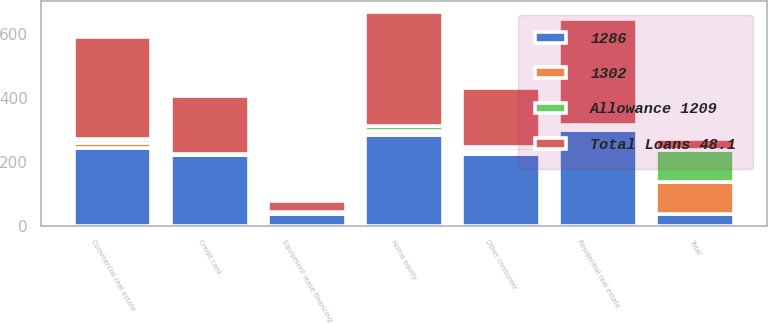Convert chart to OTSL. <chart><loc_0><loc_0><loc_500><loc_500><stacked_bar_chart><ecel><fcel>Commercial real estate<fcel>Equipment lease financing<fcel>Home equity<fcel>Residential real estate<fcel>Credit card<fcel>Other consumer<fcel>Total<nl><fcel>1286<fcel>244<fcel>36<fcel>284<fcel>300<fcel>220<fcel>225<fcel>35.5<nl><fcel>1302<fcel>13.1<fcel>3.6<fcel>12.9<fcel>7.8<fcel>2.6<fcel>9.9<fcel>100<nl><fcel>Total Loans 48.1<fcel>320<fcel>35<fcel>357<fcel>332<fcel>181<fcel>185<fcel>35.5<nl><fcel>Allowance 1209<fcel>13.8<fcel>3.6<fcel>14.2<fcel>7.4<fcel>2.5<fcel>10.4<fcel>100<nl></chart> 